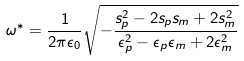<formula> <loc_0><loc_0><loc_500><loc_500>\omega ^ { * } = \frac { 1 } { 2 \pi \epsilon _ { 0 } } \sqrt { - \frac { s _ { p } ^ { 2 } - 2 s _ { p } s _ { m } + 2 s _ { m } ^ { 2 } } { \epsilon _ { p } ^ { 2 } - \epsilon _ { p } \epsilon _ { m } + 2 \epsilon _ { m } ^ { 2 } } }</formula> 